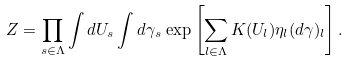<formula> <loc_0><loc_0><loc_500><loc_500>Z = \prod _ { s \in \Lambda } \int d U _ { s } \int d \gamma _ { s } \, \exp \left [ \sum _ { l \in \Lambda } K ( U _ { l } ) \eta _ { l } ( d \gamma ) _ { l } \right ] .</formula> 